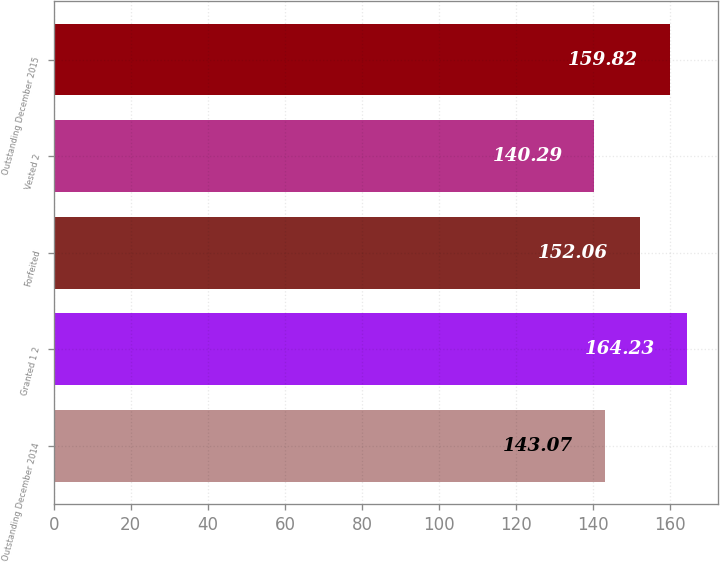<chart> <loc_0><loc_0><loc_500><loc_500><bar_chart><fcel>Outstanding December 2014<fcel>Granted 1 2<fcel>Forfeited<fcel>Vested 2<fcel>Outstanding December 2015<nl><fcel>143.07<fcel>164.23<fcel>152.06<fcel>140.29<fcel>159.82<nl></chart> 